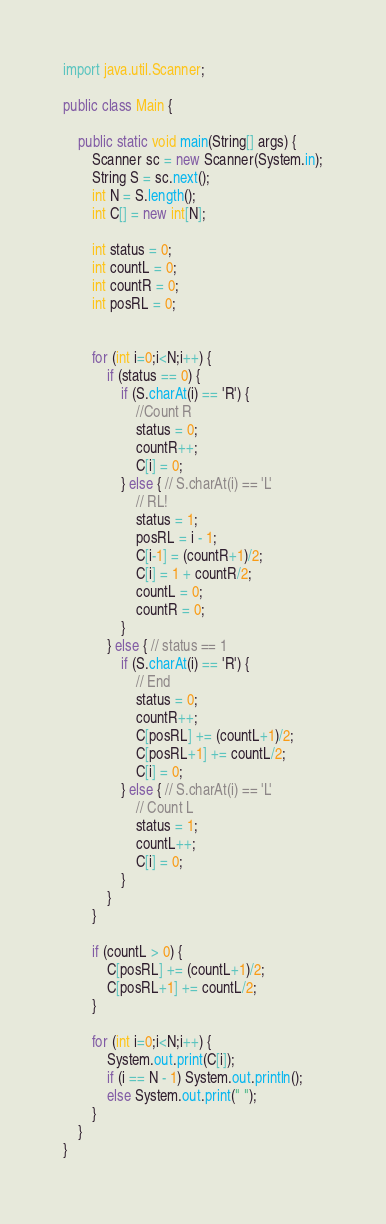<code> <loc_0><loc_0><loc_500><loc_500><_Java_>import java.util.Scanner;

public class Main {

    public static void main(String[] args) {
        Scanner sc = new Scanner(System.in);
        String S = sc.next();
        int N = S.length();
        int C[] = new int[N];

        int status = 0;
        int countL = 0;
        int countR = 0;
        int posRL = 0;


        for (int i=0;i<N;i++) {
            if (status == 0) {
                if (S.charAt(i) == 'R') {
                    //Count R
                    status = 0;
                    countR++;
                    C[i] = 0;
                } else { // S.charAt(i) == 'L'
                    // RL!
                    status = 1;
                    posRL = i - 1;
                    C[i-1] = (countR+1)/2;
                    C[i] = 1 + countR/2;
                    countL = 0;
                    countR = 0;
                }
            } else { // status == 1
                if (S.charAt(i) == 'R') {
                    // End
                    status = 0;
                    countR++;
                    C[posRL] += (countL+1)/2;
                    C[posRL+1] += countL/2;
                    C[i] = 0;
                } else { // S.charAt(i) == 'L'
                    // Count L
                    status = 1;
                    countL++;
                    C[i] = 0;
                }
            }
        }

        if (countL > 0) {
            C[posRL] += (countL+1)/2;
            C[posRL+1] += countL/2;
        }

        for (int i=0;i<N;i++) {
            System.out.print(C[i]);
            if (i == N - 1) System.out.println();
            else System.out.print(" ");
        }
    }
}
</code> 